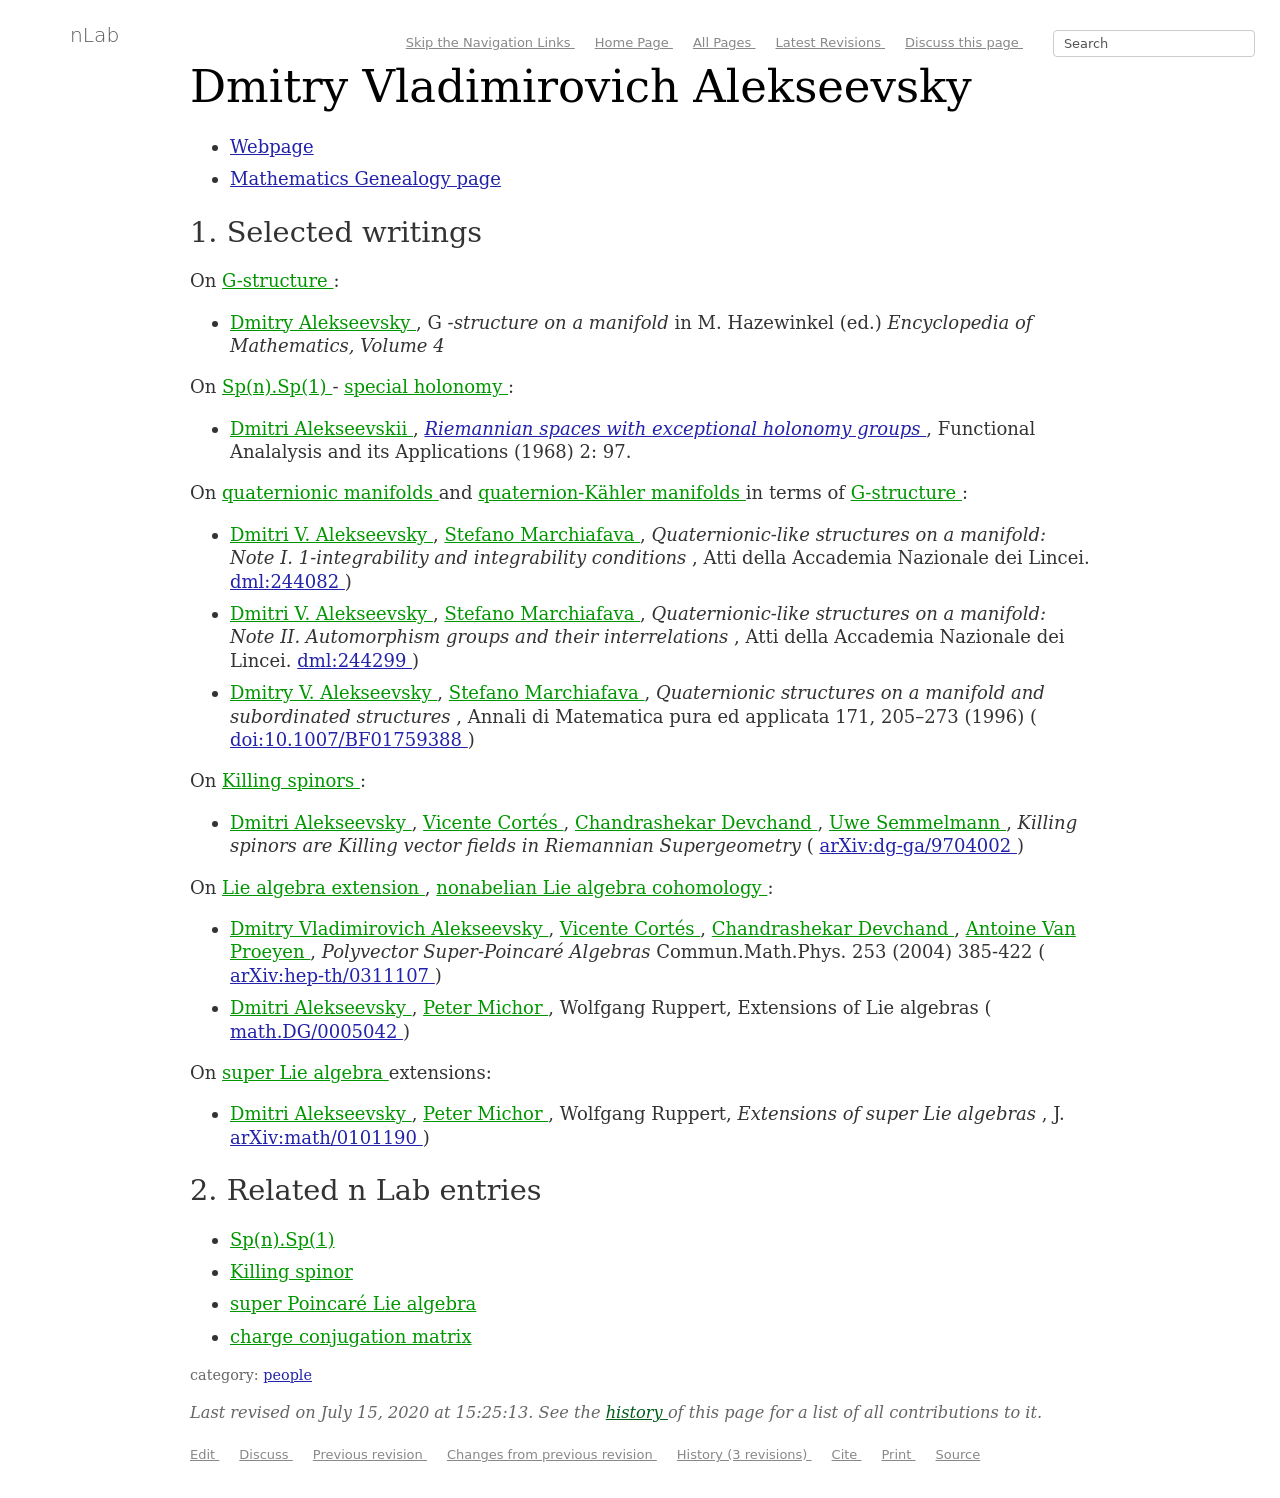Could you guide me through the process of developing this website with HTML? The process of developing a website similar to the one in the image involves using HTML for the structure, CSS for styling, and potentially JavaScript for additional interactivity. Begin by structuring the HTML with elements for headers, paragraphs, and lists similar to those structured writings about Dmitry Vladimirovich Alekseevsky on the webpage. Use CSS to style the navigation links, contents, and body text, mimicking the scholarly and clean design depicted. 